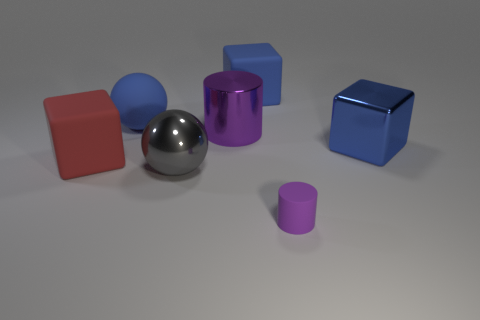The purple thing that is left of the big matte cube that is behind the red cube is what shape?
Provide a succinct answer. Cylinder. How many matte cylinders have the same size as the matte sphere?
Offer a terse response. 0. Are any tiny rubber objects visible?
Provide a short and direct response. Yes. Are there any other things of the same color as the metallic cylinder?
Keep it short and to the point. Yes. There is a big gray object that is made of the same material as the large cylinder; what shape is it?
Provide a short and direct response. Sphere. What color is the cylinder that is behind the purple cylinder that is in front of the big metallic thing on the right side of the big cylinder?
Your response must be concise. Purple. Are there the same number of large rubber things that are in front of the tiny object and big matte spheres?
Ensure brevity in your answer.  No. Are there any other things that are the same material as the big cylinder?
Keep it short and to the point. Yes. Is the color of the small matte cylinder the same as the cylinder that is behind the tiny purple rubber object?
Offer a terse response. Yes. Are there any blue shiny cubes that are behind the cylinder that is to the left of the purple cylinder in front of the red object?
Your answer should be very brief. No. 